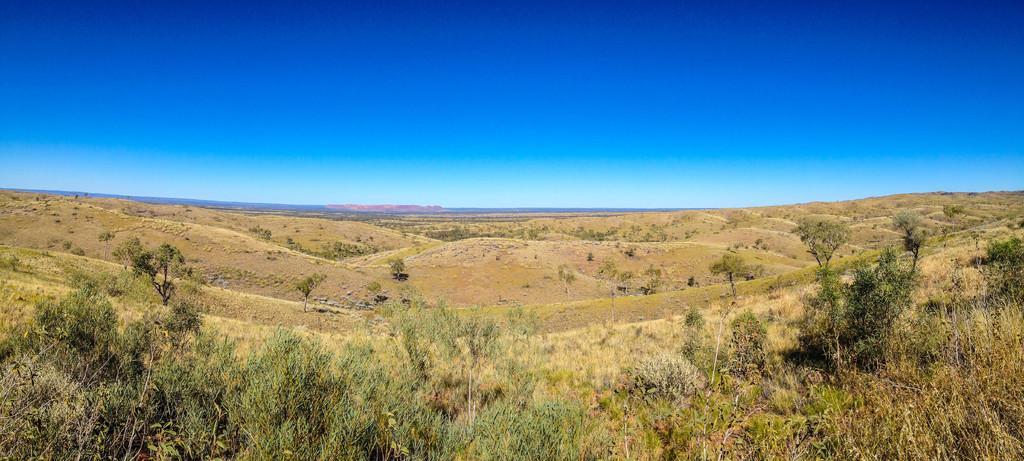Please provide a concise description of this image. In this image I can see an open grass ground and number of trees on it. In the background I can see the sky. 